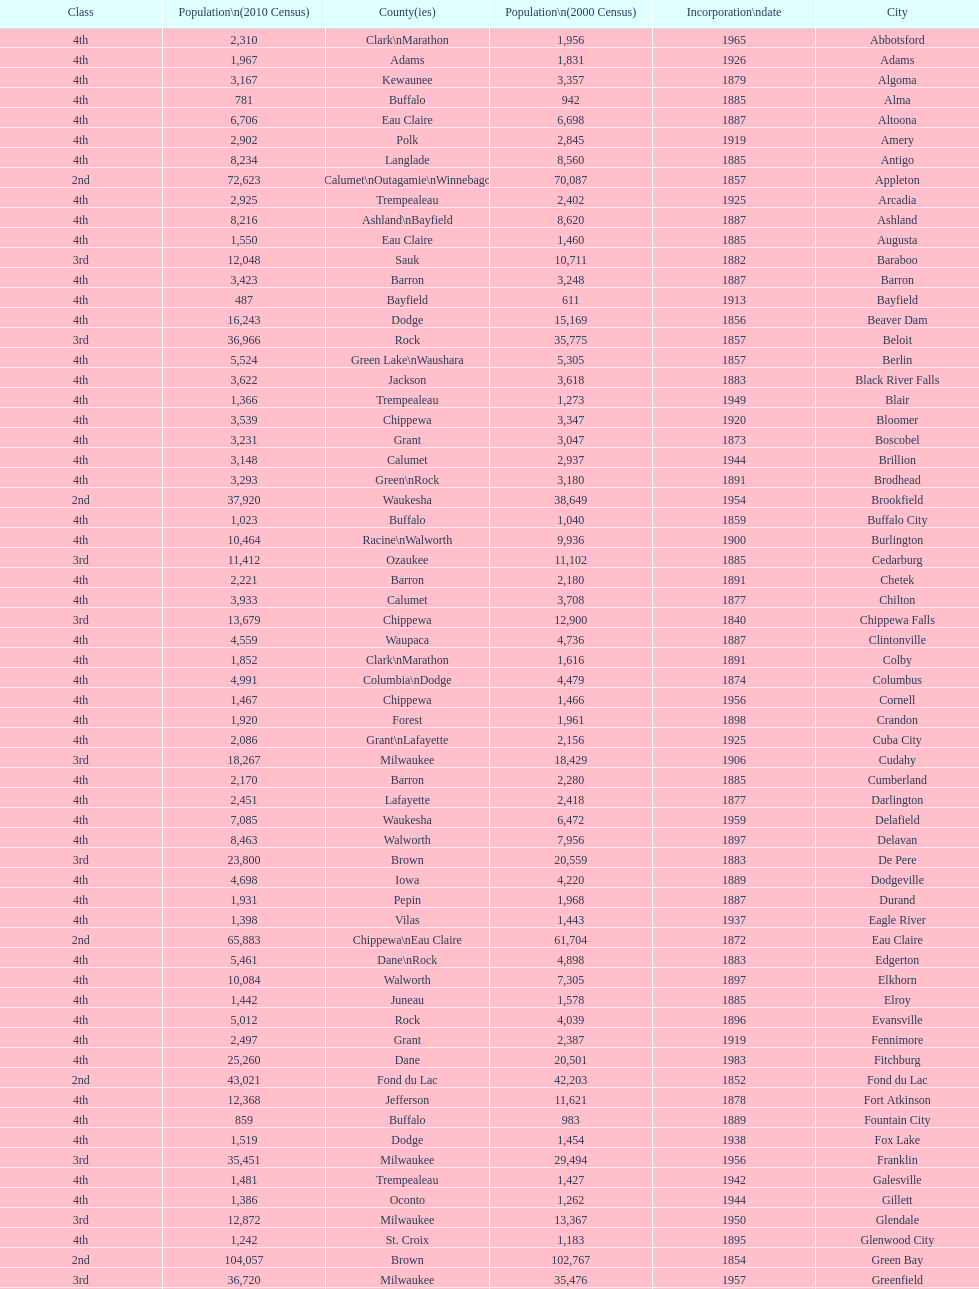Which city in wisconsin is the most populous, based on the 2010 census? Milwaukee. 